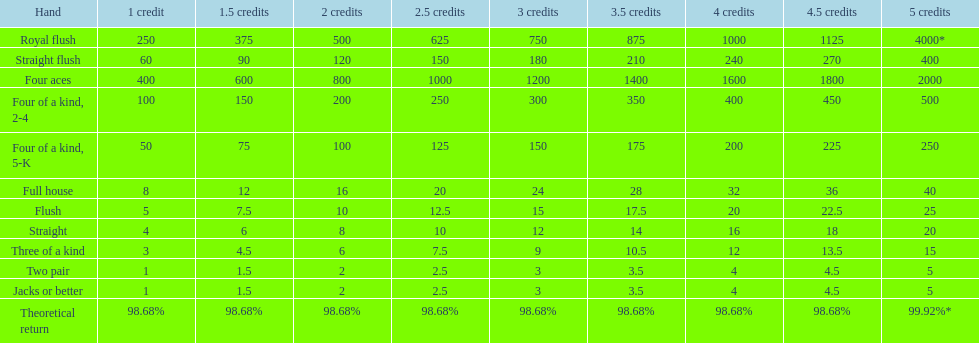What is the difference of payout on 3 credits, between a straight flush and royal flush? 570. 